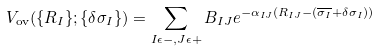<formula> <loc_0><loc_0><loc_500><loc_500>V _ { \text {ov} } ( \{ R _ { I } \} ; \{ \delta \sigma _ { I } \} ) = \sum _ { I \epsilon - , J \epsilon + } B _ { I J } e ^ { - \alpha _ { I J } ( R _ { I J } - ( \overline { \sigma _ { I } } + \delta \sigma _ { I } ) ) }</formula> 